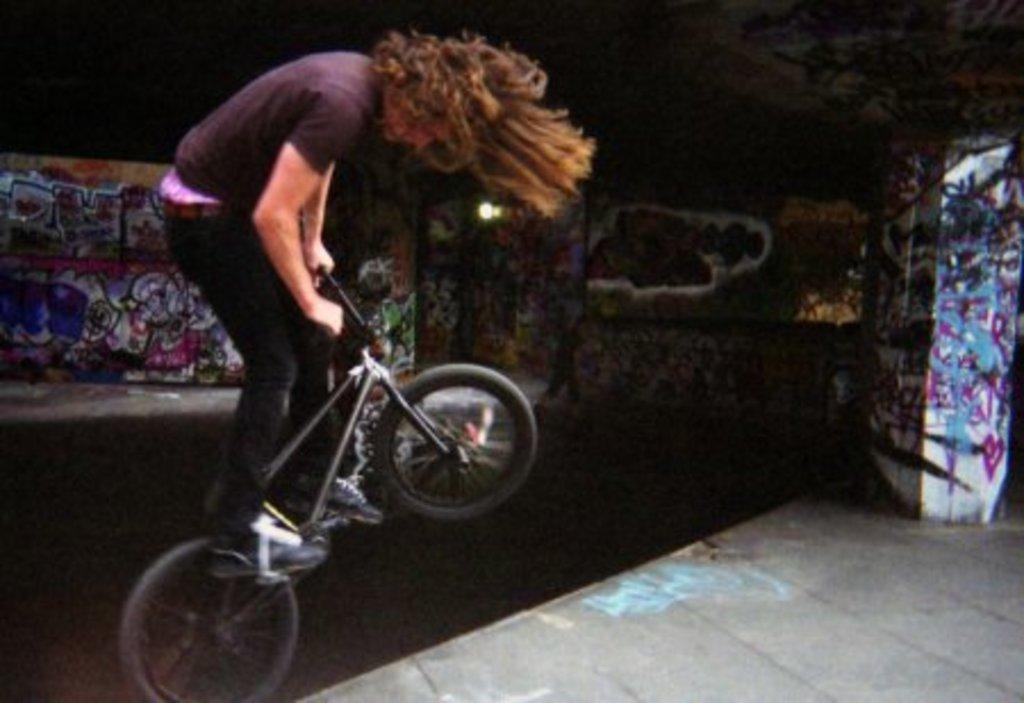In one or two sentences, can you explain what this image depicts? In this picture there is a person who is cycling on the left side of the image and there are posters in the background area of the image. 